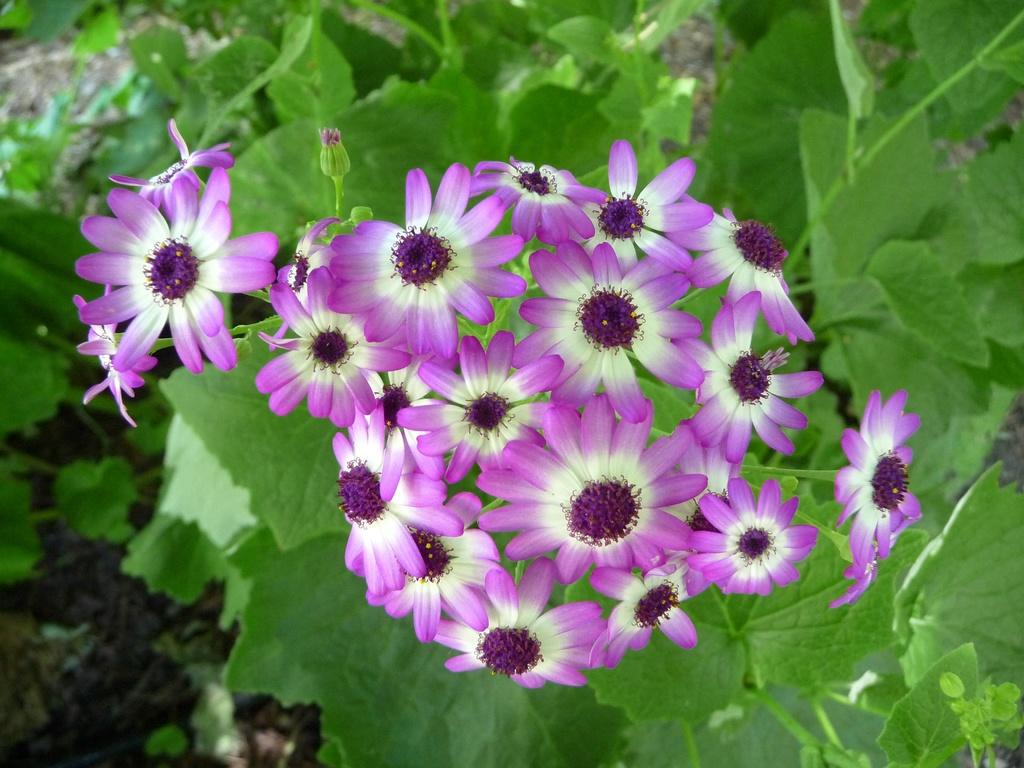What type of plants can be seen in the front of the image? There are flowers in the front of the image. What can be seen in the background of the image? There are leaves visible in the background of the image. What type of meat is being cooked in the background of the image? There is no meat or cooking activity present in the image; it features flowers in the front and leaves in the background. 